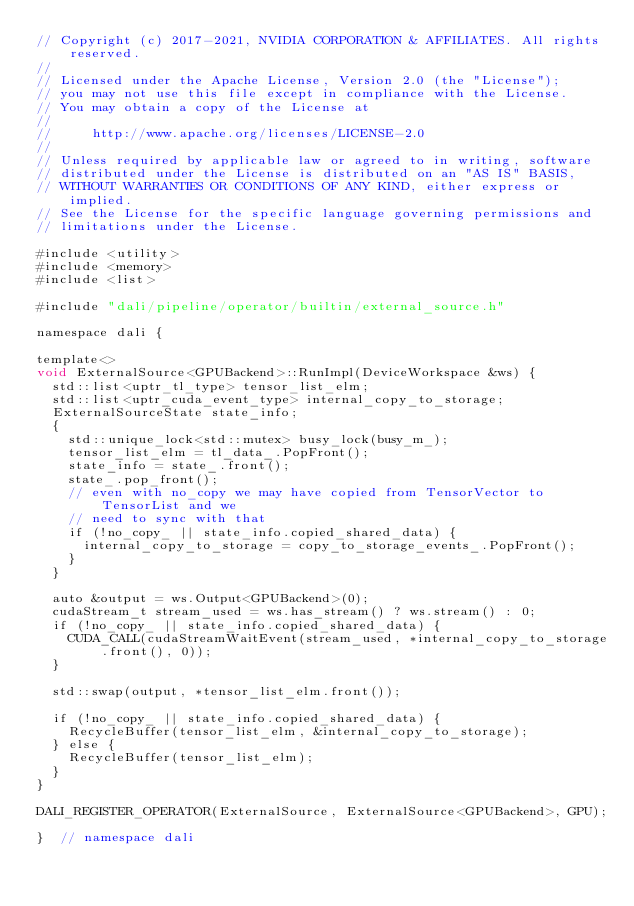<code> <loc_0><loc_0><loc_500><loc_500><_Cuda_>// Copyright (c) 2017-2021, NVIDIA CORPORATION & AFFILIATES. All rights reserved.
//
// Licensed under the Apache License, Version 2.0 (the "License");
// you may not use this file except in compliance with the License.
// You may obtain a copy of the License at
//
//     http://www.apache.org/licenses/LICENSE-2.0
//
// Unless required by applicable law or agreed to in writing, software
// distributed under the License is distributed on an "AS IS" BASIS,
// WITHOUT WARRANTIES OR CONDITIONS OF ANY KIND, either express or implied.
// See the License for the specific language governing permissions and
// limitations under the License.

#include <utility>
#include <memory>
#include <list>

#include "dali/pipeline/operator/builtin/external_source.h"

namespace dali {

template<>
void ExternalSource<GPUBackend>::RunImpl(DeviceWorkspace &ws) {
  std::list<uptr_tl_type> tensor_list_elm;
  std::list<uptr_cuda_event_type> internal_copy_to_storage;
  ExternalSourceState state_info;
  {
    std::unique_lock<std::mutex> busy_lock(busy_m_);
    tensor_list_elm = tl_data_.PopFront();
    state_info = state_.front();
    state_.pop_front();
    // even with no_copy we may have copied from TensorVector to TensorList and we
    // need to sync with that
    if (!no_copy_ || state_info.copied_shared_data) {
      internal_copy_to_storage = copy_to_storage_events_.PopFront();
    }
  }

  auto &output = ws.Output<GPUBackend>(0);
  cudaStream_t stream_used = ws.has_stream() ? ws.stream() : 0;
  if (!no_copy_ || state_info.copied_shared_data) {
    CUDA_CALL(cudaStreamWaitEvent(stream_used, *internal_copy_to_storage.front(), 0));
  }

  std::swap(output, *tensor_list_elm.front());

  if (!no_copy_ || state_info.copied_shared_data) {
    RecycleBuffer(tensor_list_elm, &internal_copy_to_storage);
  } else {
    RecycleBuffer(tensor_list_elm);
  }
}

DALI_REGISTER_OPERATOR(ExternalSource, ExternalSource<GPUBackend>, GPU);

}  // namespace dali
</code> 